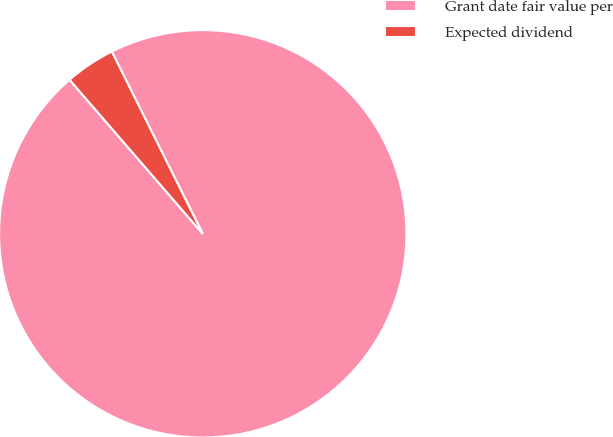Convert chart. <chart><loc_0><loc_0><loc_500><loc_500><pie_chart><fcel>Grant date fair value per<fcel>Expected dividend<nl><fcel>96.02%<fcel>3.98%<nl></chart> 